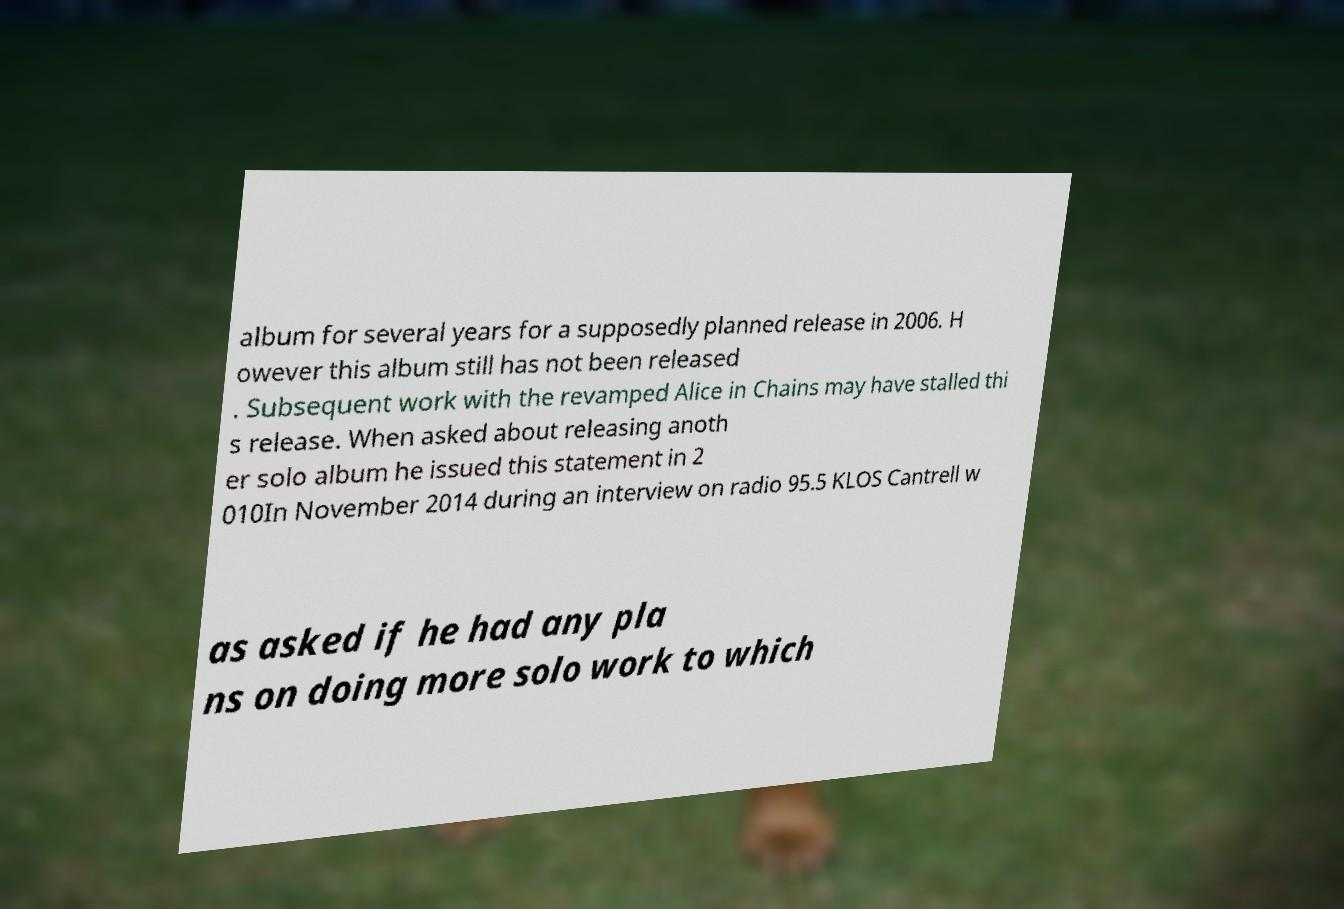Can you accurately transcribe the text from the provided image for me? album for several years for a supposedly planned release in 2006. H owever this album still has not been released . Subsequent work with the revamped Alice in Chains may have stalled thi s release. When asked about releasing anoth er solo album he issued this statement in 2 010In November 2014 during an interview on radio 95.5 KLOS Cantrell w as asked if he had any pla ns on doing more solo work to which 